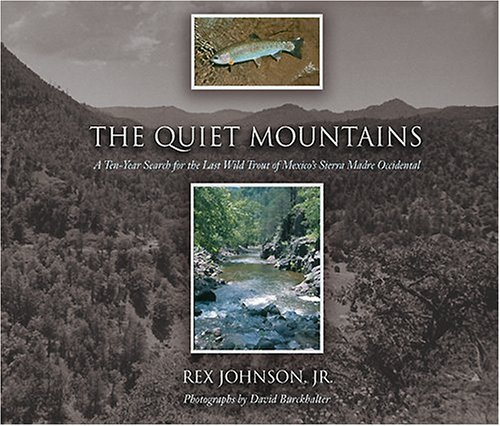Is this a motivational book? While not directly categorized as a motivational book, 'The Quiet Mountains' could inspire readers interested in nature, conservation, and personal quests. 